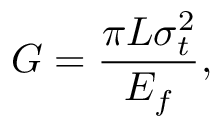<formula> <loc_0><loc_0><loc_500><loc_500>G = \frac { \pi L \sigma _ { t } ^ { 2 } } { E _ { f } } ,</formula> 